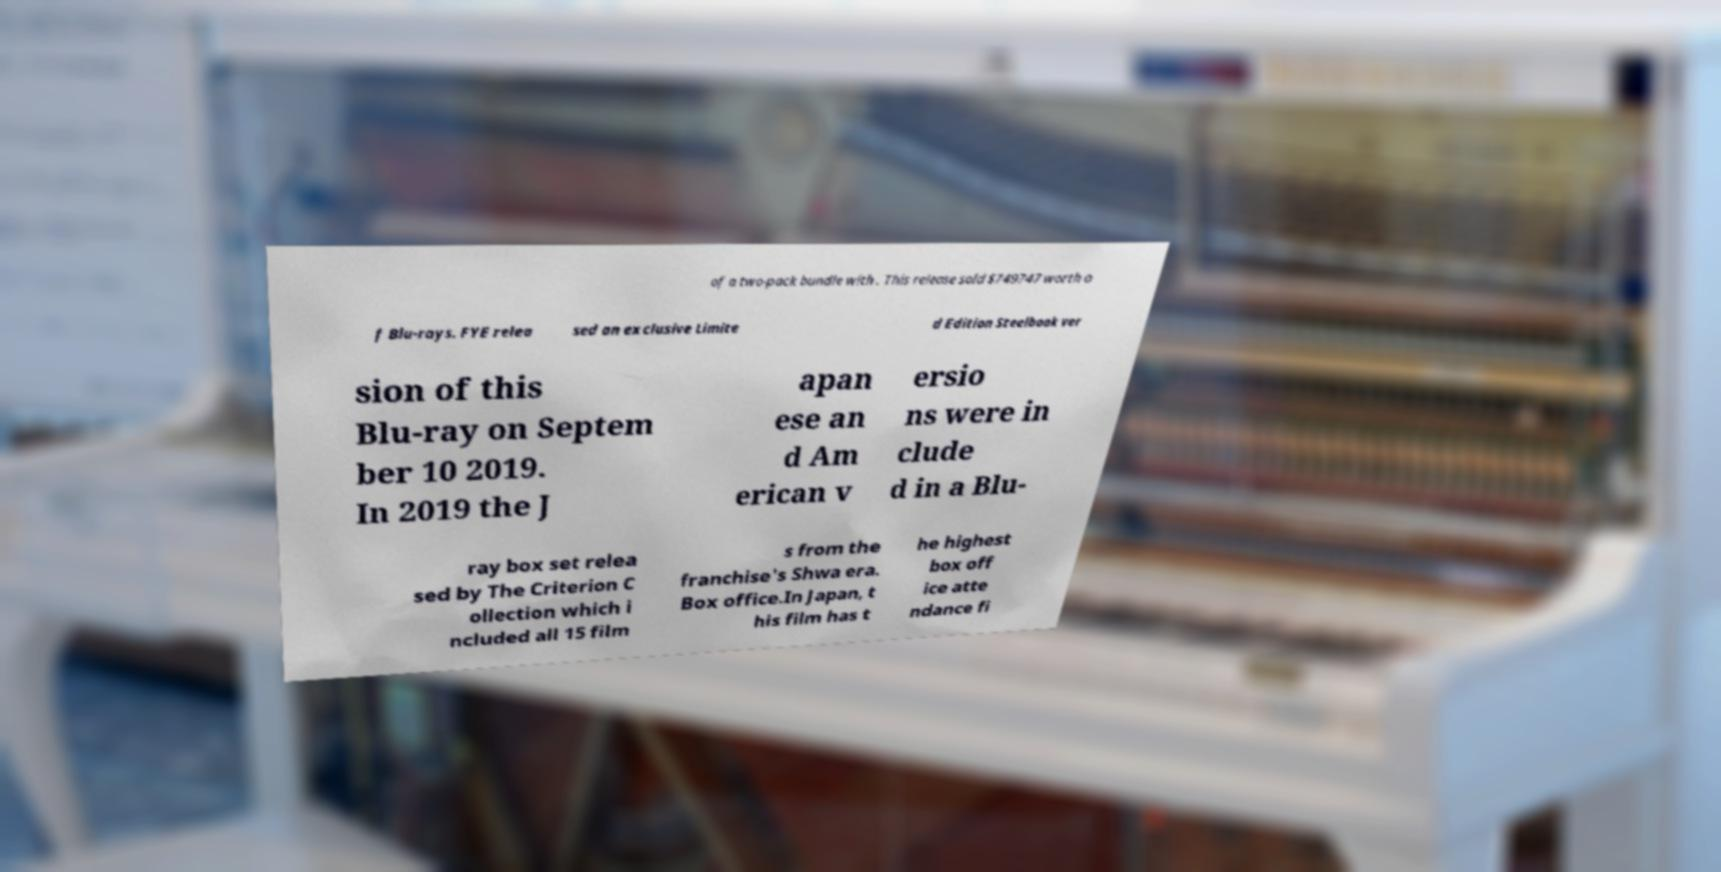There's text embedded in this image that I need extracted. Can you transcribe it verbatim? of a two-pack bundle with . This release sold $749747 worth o f Blu-rays. FYE relea sed an exclusive Limite d Edition Steelbook ver sion of this Blu-ray on Septem ber 10 2019. In 2019 the J apan ese an d Am erican v ersio ns were in clude d in a Blu- ray box set relea sed by The Criterion C ollection which i ncluded all 15 film s from the franchise's Shwa era. Box office.In Japan, t his film has t he highest box off ice atte ndance fi 